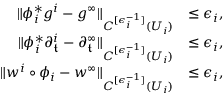Convert formula to latex. <formula><loc_0><loc_0><loc_500><loc_500>\begin{array} { r l } { \| \phi _ { i } ^ { * } g ^ { i } - g ^ { \infty } \| _ { C ^ { [ \epsilon _ { i } ^ { - 1 } ] } ( U _ { i } ) } } & { \leq \epsilon _ { i } , } \\ { \| \phi _ { i } ^ { * } \partial _ { \mathfrak { t } } ^ { i } - \partial _ { \mathfrak { t } } ^ { \infty } \| _ { C ^ { [ \epsilon _ { i } ^ { - 1 } ] } ( U _ { i } ) } } & { \leq \epsilon _ { i } , } \\ { \| w ^ { i } \circ \phi _ { i } - w ^ { \infty } \| _ { C ^ { [ \epsilon _ { i } ^ { - 1 } ] } ( U _ { i } ) } } & { \leq \epsilon _ { i } , } \end{array}</formula> 